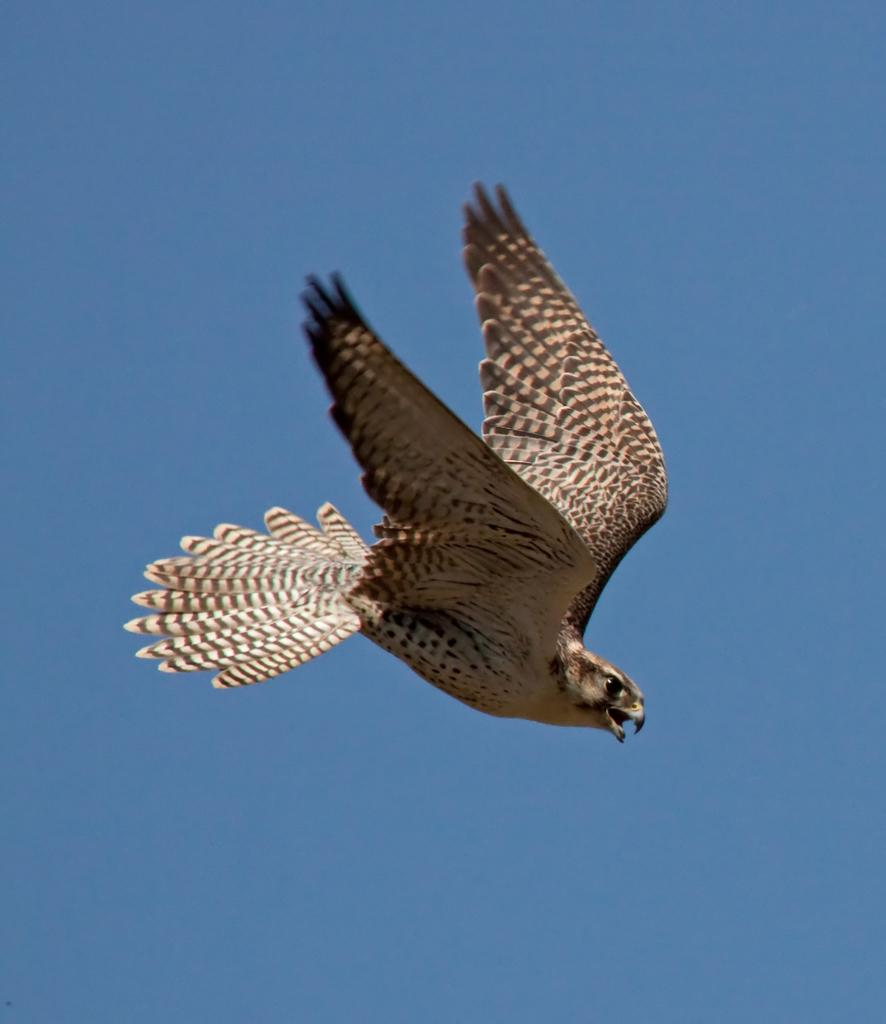What type of animal is present in the image? There is a bird in the image. What color is the background of the image? The background of the image is blue. Where is the party taking place in the image? There is no party present in the image; it only features a bird against a blue background. What type of utensil can be seen on the floor in the image? There is no utensil, such as a spoon, present on the floor in the image. 